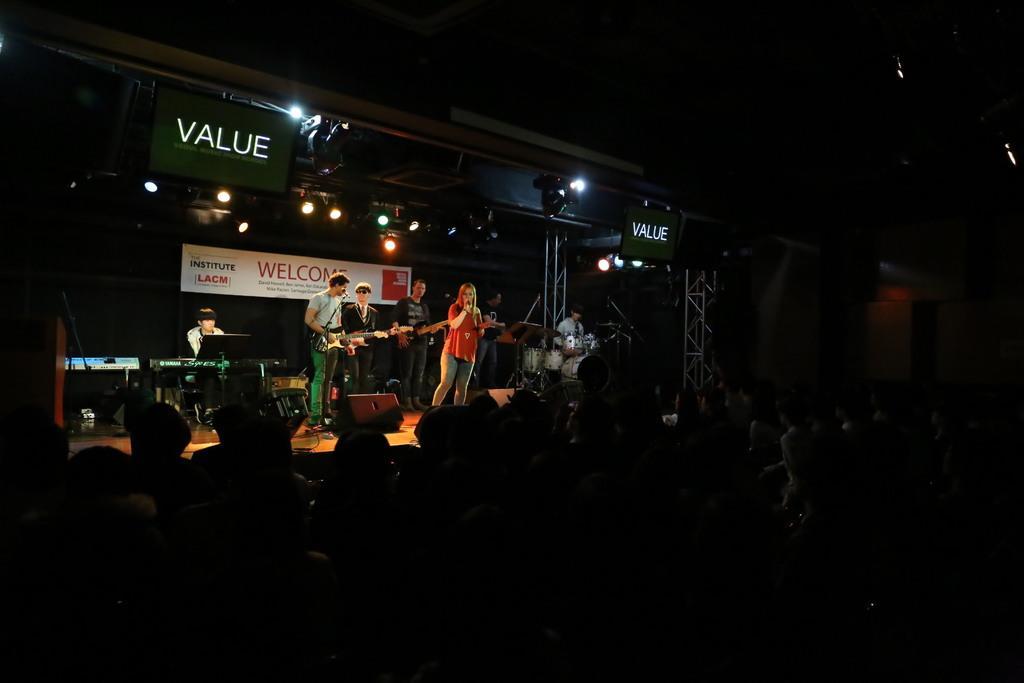In one or two sentences, can you explain what this image depicts? In this image there are some persons are playing some instruments on the stage and there are some persons standing in the bottom of this image , and there are some lights arranged on the top of this image. 